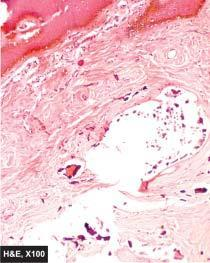what does the subcutaneous tissue show?
Answer the question using a single word or phrase. Masses or nodules of calcium salt surrounded by foreign body giant cells 